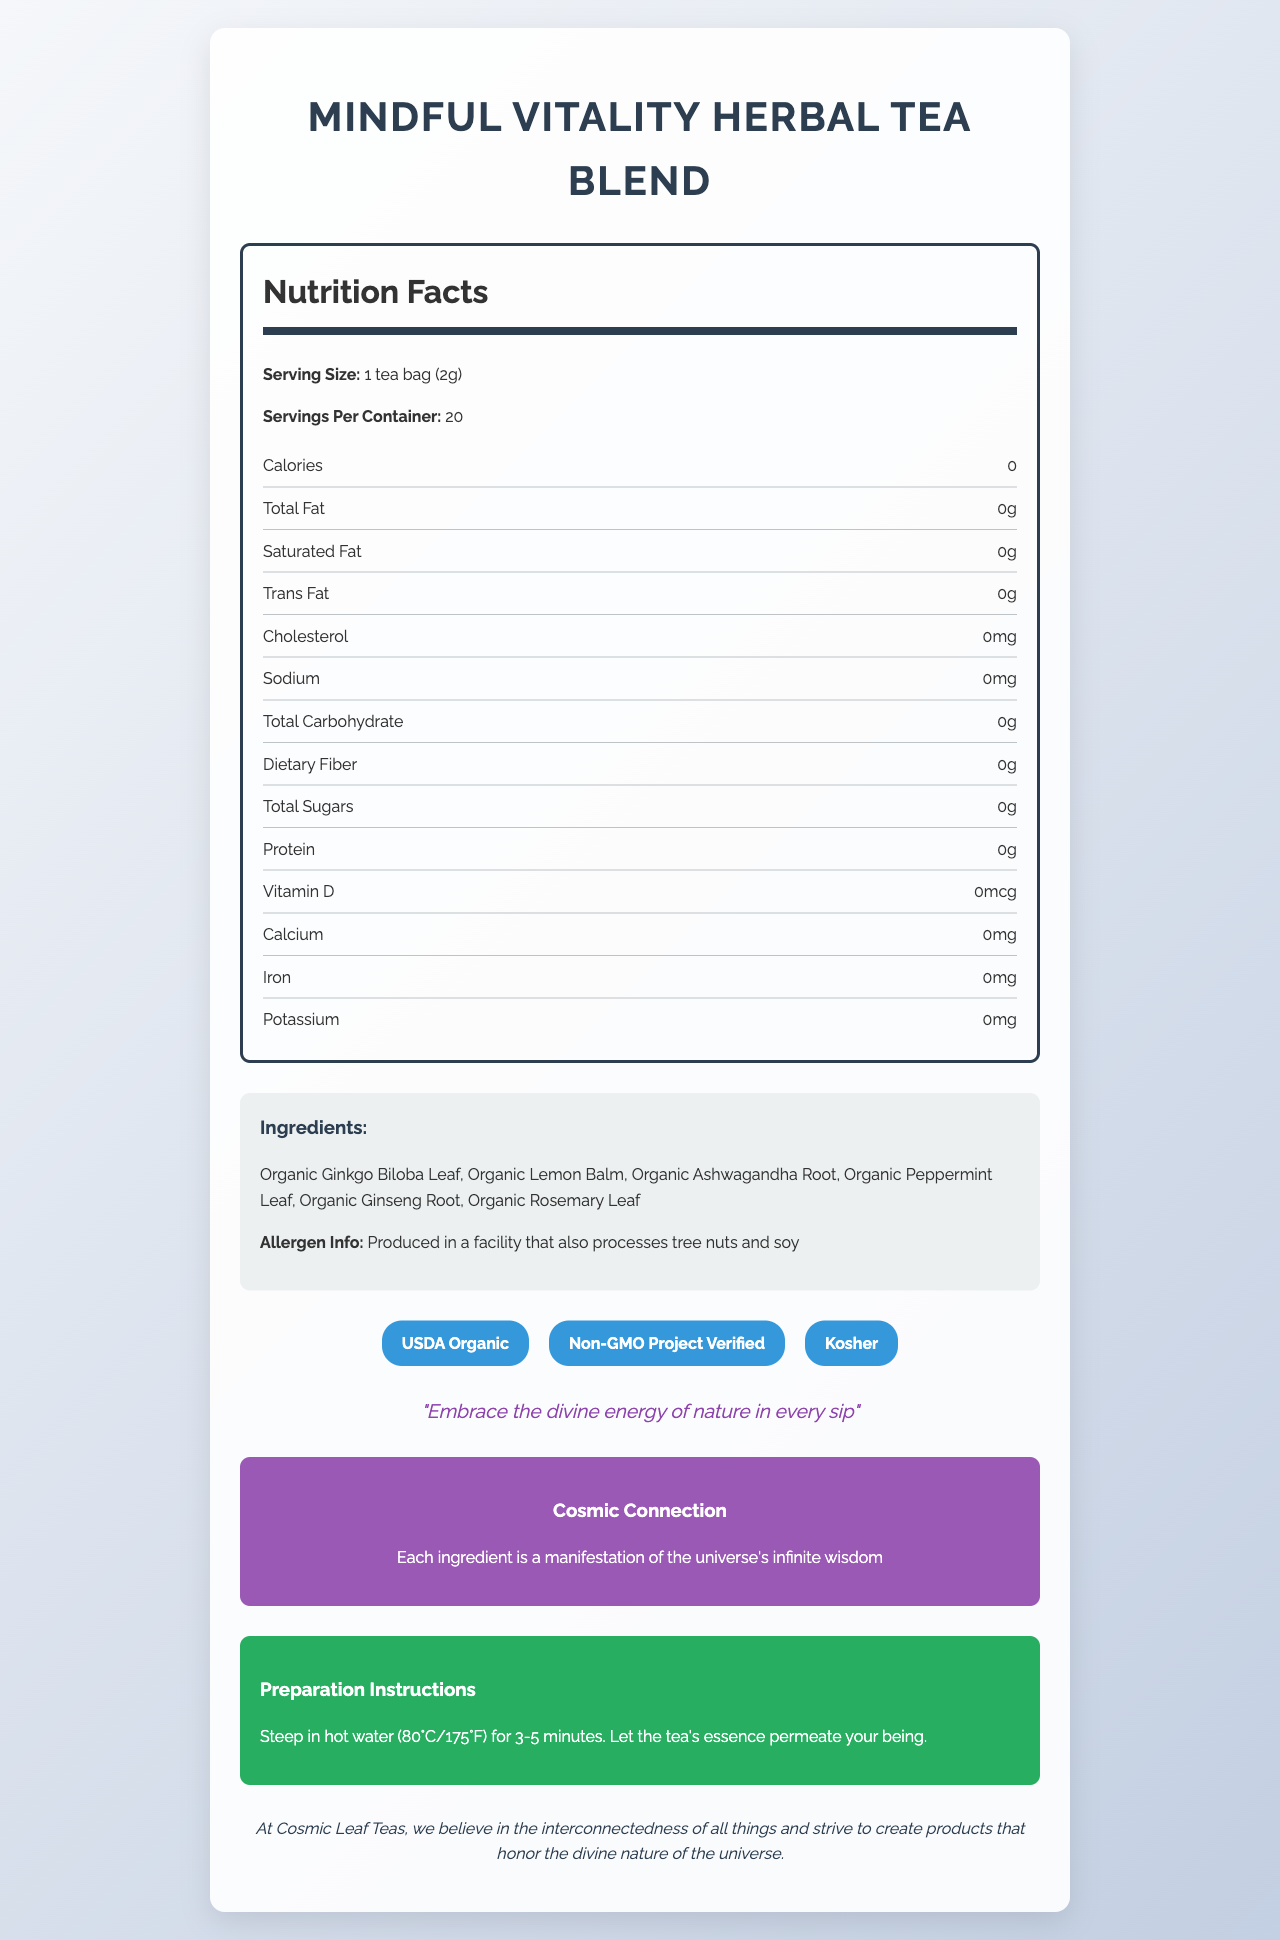what is the serving size for the Mindful Vitality Herbal Tea Blend? The serving size is specified in the nutrition facts section of the document.
Answer: 1 tea bag (2g) how many servings are there per container? The servings per container are mentioned right under the serving size in the nutrition facts section.
Answer: 20 what are the three certifications mentioned for this tea? The certifications are listed in the certifications section.
Answer: USDA Organic, Non-GMO Project Verified, Kosher who makes the Mindful Vitality Herbal Tea Blend? The company responsible for this product is noted in the company philosophy section.
Answer: Cosmic Leaf Teas what is the calorie count per serving? The calorie count is clearly mentioned in the nutrition facts section.
Answer: 0 which ingredient is not organic? A. Organic Lemon Balm B. Organic Ginkgo Biloba Leaf C. Organic Peppermint Leaf D. None of the above All the listed ingredients are organic, as specified in the ingredients section.
Answer: D. None of the above how should the tea be prepared? A. Steep in hot water for 3-5 minutes B. Boil in hot water for 5 minutes C. Let it simmer for 10 minutes The preparation instructions clearly state to steep the tea in hot water (80°C/175°F) for 3-5 minutes.
Answer: A. Steep in hot water for 3-5 minutes are there any allergens? Yes/No The allergen information states that the product is produced in a facility that also processes tree nuts and soy.
Answer: Yes what is the pantheistic quote associated with the product? The quote is highlighted in the pantheistic statement section of the document.
Answer: Embrace the divine energy of nature in every sip can the nutritional value of protein be determined from the document? The nutrition facts section indicates the protein content as 0g per serving.
Answer: Yes summarize the main idea of the document. The summary includes a detailed description of the different sections of the document and how they contribute to the overall portrayal of the product's benefits and values.
Answer: The document provides detailed information about the Mindful Vitality Herbal Tea Blend, including its nutritional facts, ingredient list, certifications, allergen information, and various brand philosophies and features. The tea is designed to promote mindfulness and vitality, is non-GMO, all-natural, and has no calories, fat, or sugar. Instructions for preparation and philosophical notes on the interconnectedness of nature are also included. does the document indicate the tea blend's flavor profile? The document does not mention anything specific about the tea blend's flavor profile.
Answer: Not enough information what is the sustainability note mentioned in the document? The sustainability note is clearly stated towards the end of the document.
Answer: Packaging made from 100% recycled materials 